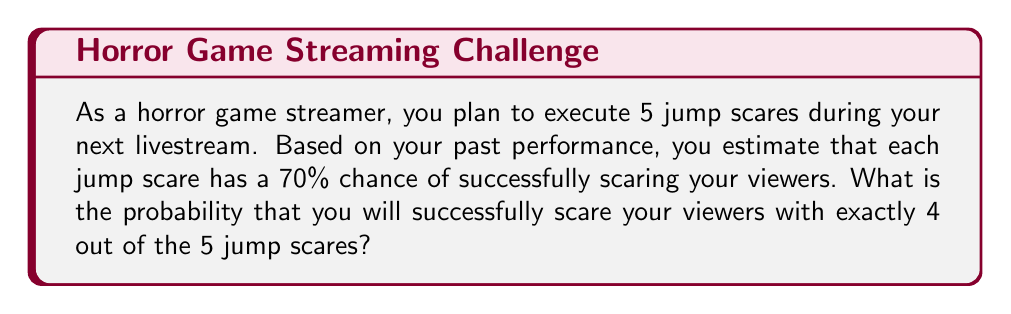Can you solve this math problem? To solve this problem, we can use the binomial probability formula:

$$ P(X = k) = \binom{n}{k} p^k (1-p)^{n-k} $$

Where:
- $n$ is the number of trials (jump scares)
- $k$ is the number of successes (successful scares)
- $p$ is the probability of success on each trial

Given:
- $n = 5$ (total number of jump scares)
- $k = 4$ (number of successful scares we want)
- $p = 0.70$ (probability of success for each scare)

Step 1: Calculate the binomial coefficient $\binom{n}{k}$
$$ \binom{5}{4} = \frac{5!}{4!(5-4)!} = \frac{5!}{4!1!} = 5 $$

Step 2: Calculate $p^k$
$$ 0.70^4 = 0.2401 $$

Step 3: Calculate $(1-p)^{n-k}$
$$ (1-0.70)^{5-4} = 0.30^1 = 0.30 $$

Step 4: Multiply all components
$$ P(X = 4) = 5 \times 0.2401 \times 0.30 = 0.36015 $$

Therefore, the probability of successfully scaring viewers with exactly 4 out of 5 jump scares is approximately 0.36015 or 36.015%.
Answer: 0.36015 